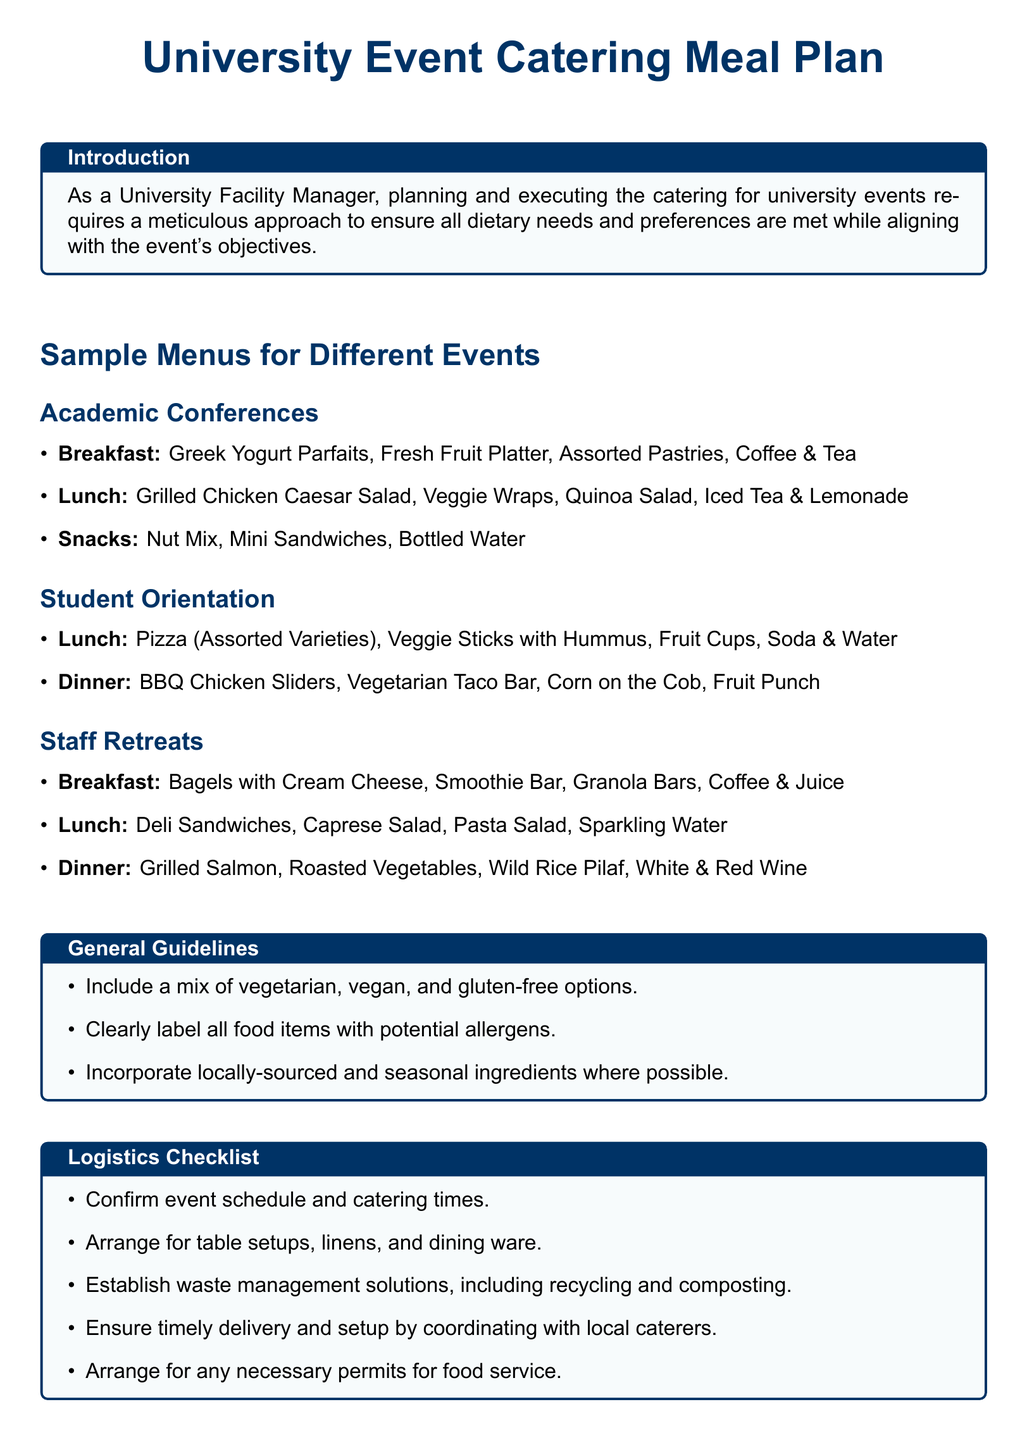What is included in the breakfast for Academic Conferences? The breakfast menu includes Greek Yogurt Parfaits, Fresh Fruit Platter, Assorted Pastries, Coffee & Tea.
Answer: Greek Yogurt Parfaits, Fresh Fruit Platter, Assorted Pastries, Coffee & Tea What are the options for lunch during Student Orientation? The lunch options are Pizza (Assorted Varieties), Veggie Sticks with Hummus, Fruit Cups, Soda & Water.
Answer: Pizza (Assorted Varieties), Veggie Sticks with Hummus, Fruit Cups, Soda & Water What dietary options should be included according to General Guidelines? The General Guidelines suggest including a mix of vegetarian, vegan, and gluten-free options.
Answer: Vegetarian, vegan, and gluten-free options How many types of dinners are provided in the Staff Retreats? There are three types of dinner items listed for Staff Retreats in the document.
Answer: Three What is the purpose of the Logistics Checklist section? The Logistics Checklist is designed to outline necessary arrangements and confirm details for the catering services at events.
Answer: Outline necessary arrangements and confirm details What type of beverages are served for dinner in Staff Retreats? The dinner in Staff Retreats includes White & Red Wine as beverage options.
Answer: White & Red Wine What should be established according to the Logistics Checklist? The Logistics Checklist suggests establishing waste management solutions, including recycling and composting.
Answer: Waste management solutions Which meal includes BBQ Chicken Sliders? BBQ Chicken Sliders are included in the dinner for Student Orientation.
Answer: Dinner for Student Orientation What do the General Guidelines recommend regarding allergens? The General Guidelines recommend clearly labeling all food items with potential allergens.
Answer: Clearly labeling all food items with potential allergens 